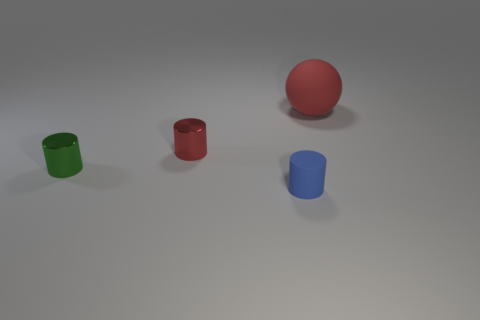Subtract all red cylinders. How many cylinders are left? 2 Add 3 red shiny cylinders. How many objects exist? 7 Subtract all blue cylinders. How many cylinders are left? 2 Subtract all spheres. How many objects are left? 3 Subtract all brown spheres. How many green cylinders are left? 1 Subtract all large spheres. Subtract all small objects. How many objects are left? 0 Add 1 small things. How many small things are left? 4 Add 4 tiny blue cylinders. How many tiny blue cylinders exist? 5 Subtract 0 green cubes. How many objects are left? 4 Subtract 2 cylinders. How many cylinders are left? 1 